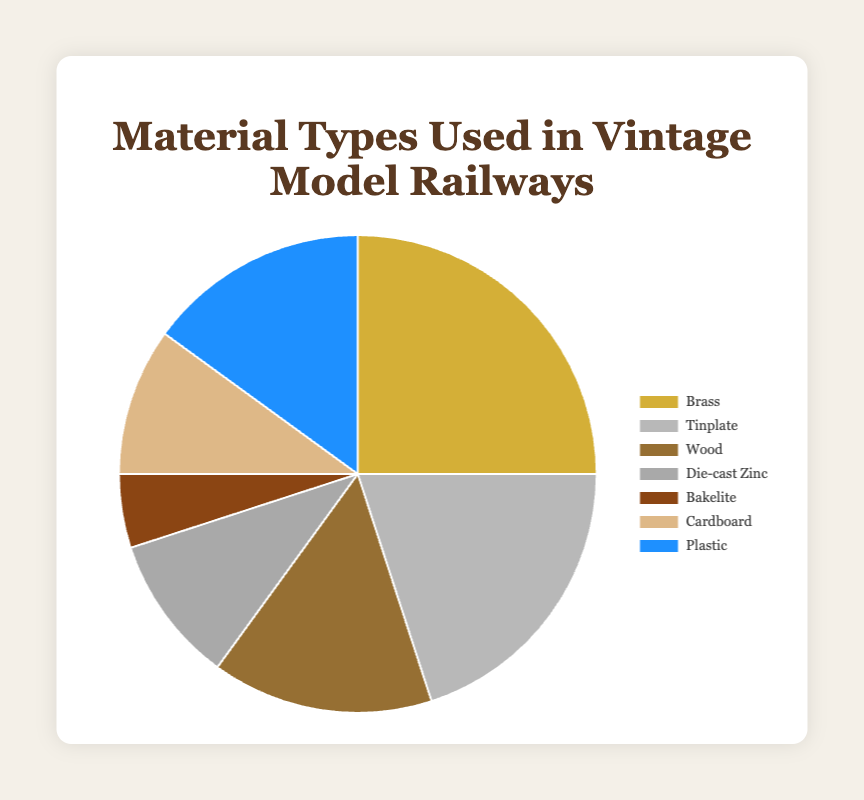Which material is used the most in vintage model railways? Referring to the pie chart, Brass has the largest section, indicating it is the most used material in vintage model railways.
Answer: Brass Which two materials have the same usage percentage in the pie chart? The pie chart shows that both Die-cast Zinc and Cardboard occupy the same amount of the circle, indicating they have the same usage percentage.
Answer: Die-cast Zinc and Cardboard How does the usage of wood compare to that of plastic? By examining the pie chart sections for Wood and Plastic, we see that both materials have the same size, signifying equal usage percentages.
Answer: Equal What is the total percentage of materials that are not metals? The non-metal materials listed are Wood (15%), Bakelite (5%), Cardboard (10%), and Plastic (15%). Summing these gives 15 + 5 + 10 + 15 = 45%.
Answer: 45% Which material type has the smallest usage percentage, and how much is it? The smallest section of the pie chart corresponds to Bakelite, which has a usage percentage of 5%.
Answer: Bakelite, 5% What is the most used metal in vintage model railways, and how much more is it compared to Tinplate? Comparing the sections for Brass (25%) and Tinplate (20%) shows that Brass is used more. The difference in their usage percentages is 25% - 20% = 5%.
Answer: Brass, 5% How does the combined usage percentage of Brass and Tinplate compare to the total usage of all other materials? The combined percentage for Brass and Tinplate is 25% + 20% = 45%. The total of all other materials is 15% (Wood) + 10% (Die-cast Zinc) + 5% (Bakelite) + 10% (Cardboard) + 15% (Plastic) = 55%. 45% (Brass and Tinplate) < 55% (Others).
Answer: Less Which materials together make up one-third of the total usage? We need materials whose sum equals approximately one-third of 100%, which is around 33.33%. The materials are Tinplate (20%) and any single material that approximately sums to 33.33%. Adding 20% (Tinplate) to Die-cast Zinc (10%) gives 30%, which is the closest combination totaling near one-third.
Answer: Tinplate and Die-cast Zinc What color represents Bakelite in the pie chart? By looking at the color legend associated with the sections, we see that Bakelite is colored brown.
Answer: Brown 